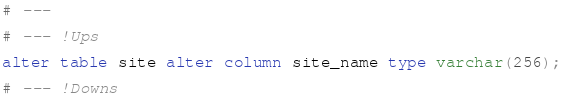<code> <loc_0><loc_0><loc_500><loc_500><_SQL_># ---

# --- !Ups

alter table site alter column site_name type varchar(256);

# --- !Downs
</code> 